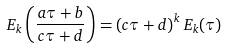<formula> <loc_0><loc_0><loc_500><loc_500>E _ { k } \left ( \frac { a \tau + b } { c \tau + d } \right ) = \left ( c \tau + d \right ) ^ { k } E _ { k } ( \tau )</formula> 